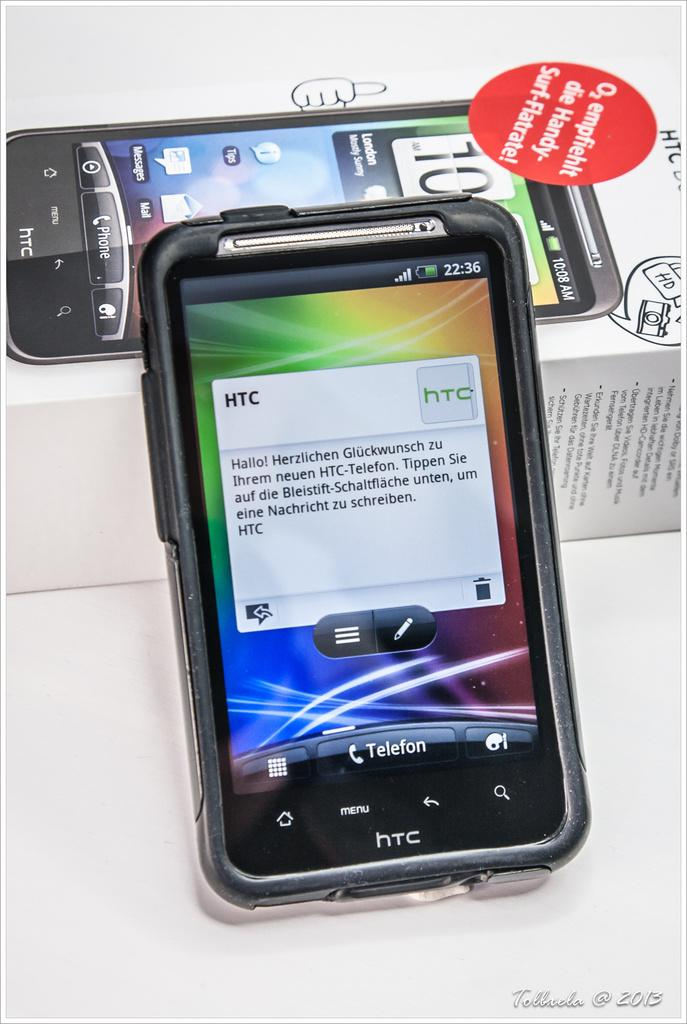What electronic device is visible in the image? There is a mobile phone in the image. What else can be seen besides the mobile phone? There is a box with text and images in the image. What color is the background of the image? The background of the image is white. Where is the text located in the image? There is some text in the bottom right side of the image. How many cows are standing on the flag in the image? There are no cows or flags present in the image. How many legs are visible in the image? The image does not show any legs; it features a mobile phone, a box with text and images, a white background, and some text. 